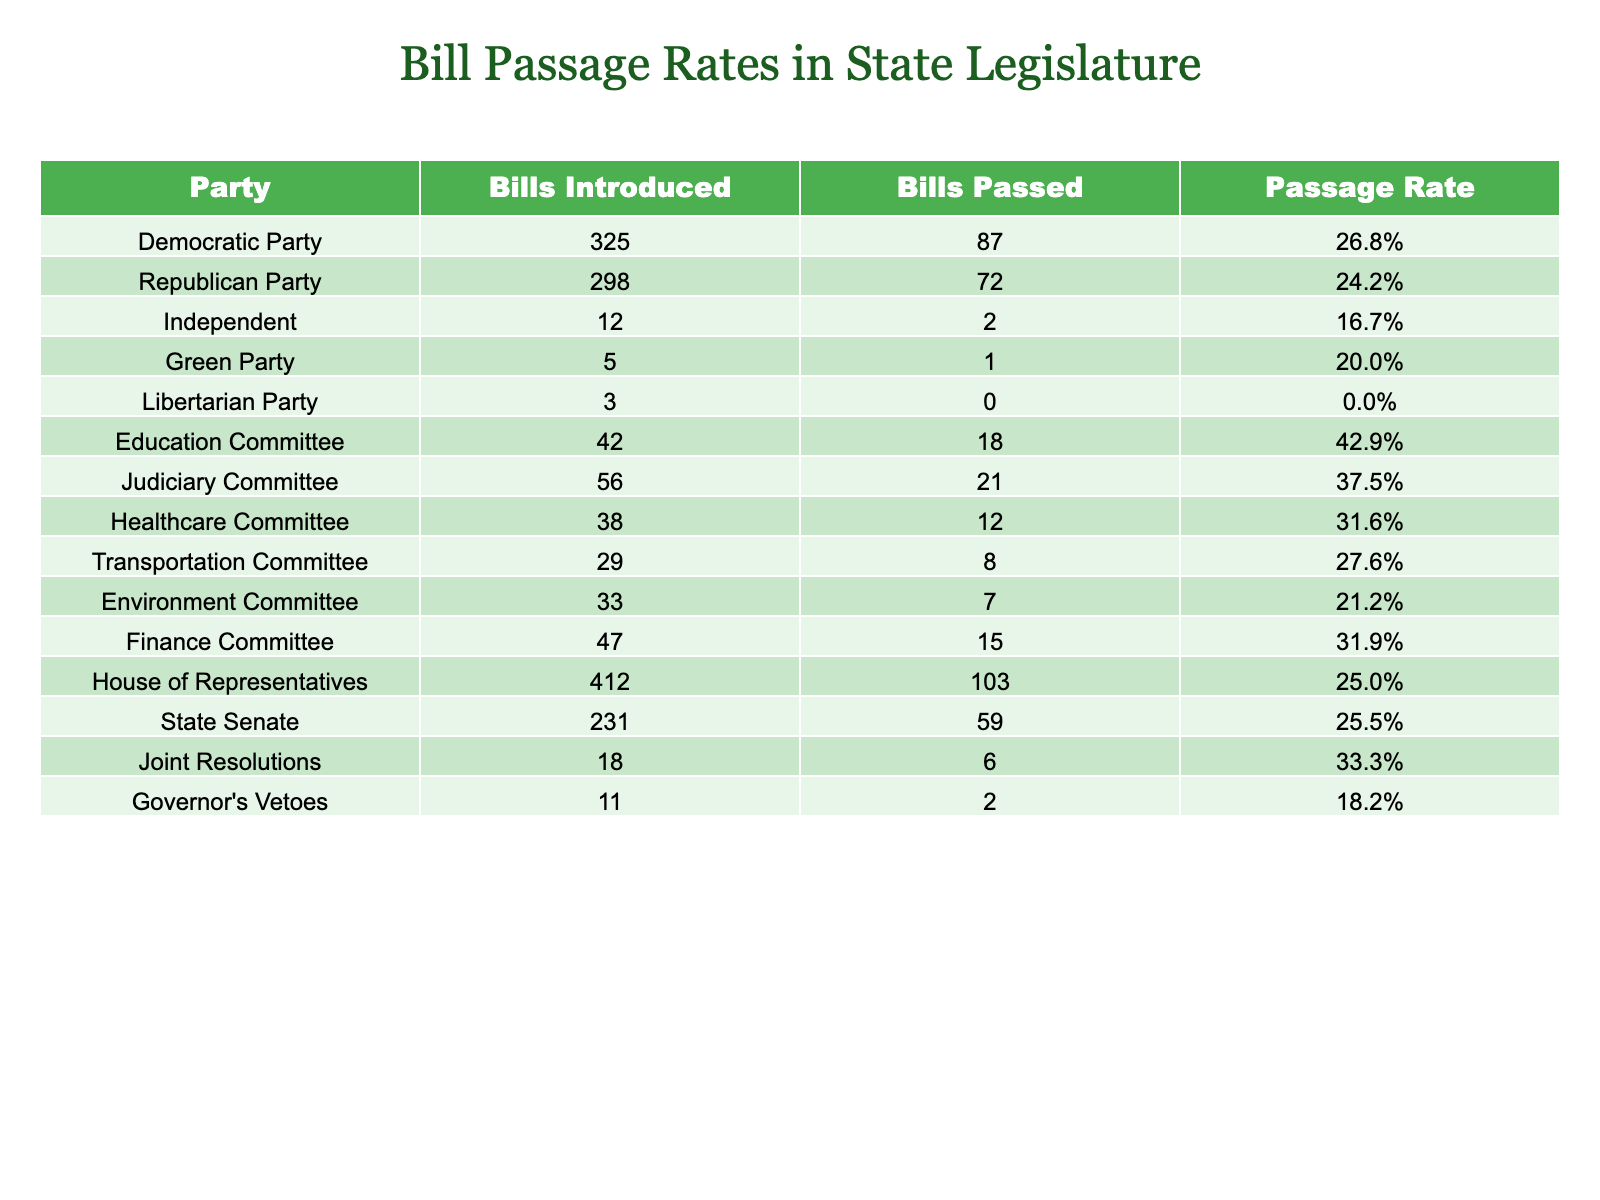What is the passage rate for the Democratic Party? The table shows that the passage rate for the Democratic Party is listed as 26.8%.
Answer: 26.8% Which party has the highest passage rate? The Education Committee has the highest passage rate at 42.9%, as shown in the table.
Answer: Education Committee How many total bills were introduced by the Republican and Democratic parties combined? The Republican Party introduced 298 bills and the Democratic Party introduced 325 bills; so, adding them together gives 298 + 325 = 623.
Answer: 623 What is the passage rate for the Independent party, and is it higher than that of the Green Party? The Independent party has a passage rate of 16.7%, while the Green Party has a passage rate of 20.0%. Since 16.7% is less than 20.0%, the Independent party's rate is not higher.
Answer: No How many more bills passed by the Judiciary Committee compared to the Green Party? The Judiciary Committee passed 21 bills, while the Green Party passed 1 bill. Therefore, the difference is 21 - 1 = 20.
Answer: 20 What is the average passage rate for all parties listed in the table? The passage rates for all entities are averaged by first summing their rates: 26.8%, 24.2%, 16.7%, 20.0%, 0.0%, 42.9%, 37.5%, 31.6%, 27.6%, 21.2%, 31.9%, 25.0%, 25.5%, 33.3%, and 18.2%, which results in a total of  356.6%. Dividing by 14 gives an average of approximately 25.4%.
Answer: 25.4% Is it true that the Libertarian Party introduced more bills than the Green Party? The Libertarian Party introduced 3 bills while the Green Party introduced 5 bills. Therefore, it is false that the Libertarian Party introduced more bills.
Answer: No Which committee had a lower passage rate than the House of Representatives? The House of Representatives had a passage rate of 25.0%. The committees with lower rates are the Environment Committee at 21.2% and the Libertarian Party at 0.0%, confirmed by examining their rates.
Answer: Environment Committee and Libertarian Party If the Governor vetoes two bills, how many bills are left for potential passage? Initially, there were a total of 1,293 bills introduced (sum of all bills introduced by each party and committee). If 2 are vetoed, then 1,293 - 2 = 1,291 bills remain for potential passage.
Answer: 1,291 